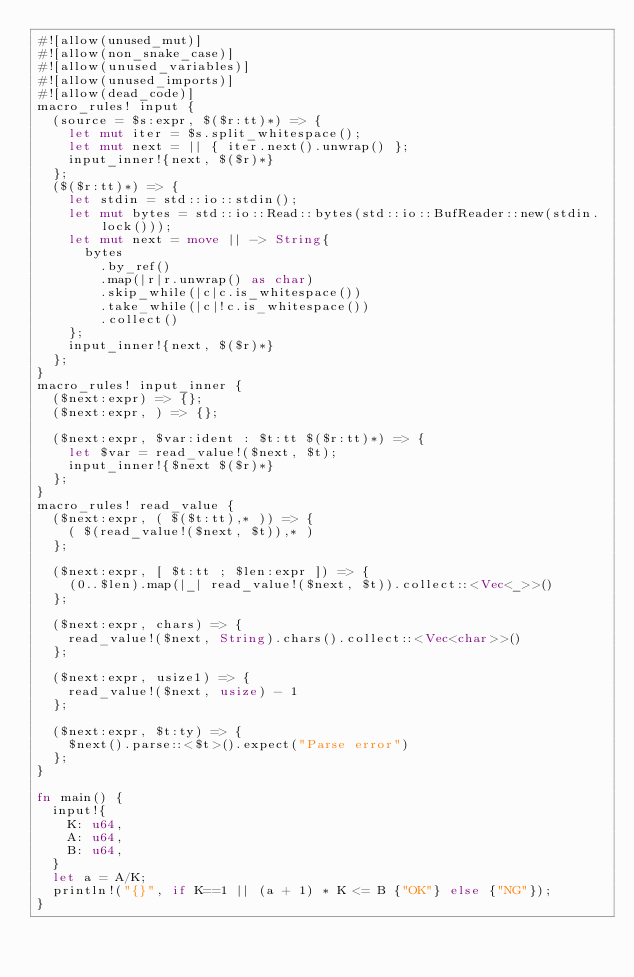<code> <loc_0><loc_0><loc_500><loc_500><_Rust_>#![allow(unused_mut)]
#![allow(non_snake_case)]
#![allow(unused_variables)]
#![allow(unused_imports)]
#![allow(dead_code)]
macro_rules! input {
  (source = $s:expr, $($r:tt)*) => {
    let mut iter = $s.split_whitespace();
    let mut next = || { iter.next().unwrap() };
    input_inner!{next, $($r)*}
  };
  ($($r:tt)*) => {
    let stdin = std::io::stdin();
    let mut bytes = std::io::Read::bytes(std::io::BufReader::new(stdin.lock()));
    let mut next = move || -> String{
      bytes
        .by_ref()
        .map(|r|r.unwrap() as char)
        .skip_while(|c|c.is_whitespace())
        .take_while(|c|!c.is_whitespace())
        .collect()
    };
    input_inner!{next, $($r)*}
  };
}
macro_rules! input_inner {
  ($next:expr) => {};
  ($next:expr, ) => {};

  ($next:expr, $var:ident : $t:tt $($r:tt)*) => {
    let $var = read_value!($next, $t);
    input_inner!{$next $($r)*}
  };
}
macro_rules! read_value {
  ($next:expr, ( $($t:tt),* )) => {
    ( $(read_value!($next, $t)),* )
  };

  ($next:expr, [ $t:tt ; $len:expr ]) => {
    (0..$len).map(|_| read_value!($next, $t)).collect::<Vec<_>>()
  };

  ($next:expr, chars) => {
    read_value!($next, String).chars().collect::<Vec<char>>()
  };

  ($next:expr, usize1) => {
    read_value!($next, usize) - 1
  };

  ($next:expr, $t:ty) => {
    $next().parse::<$t>().expect("Parse error")
  };
}

fn main() {
  input!{
    K: u64,
    A: u64,
    B: u64,
  }
  let a = A/K;
  println!("{}", if K==1 || (a + 1) * K <= B {"OK"} else {"NG"});
}
</code> 